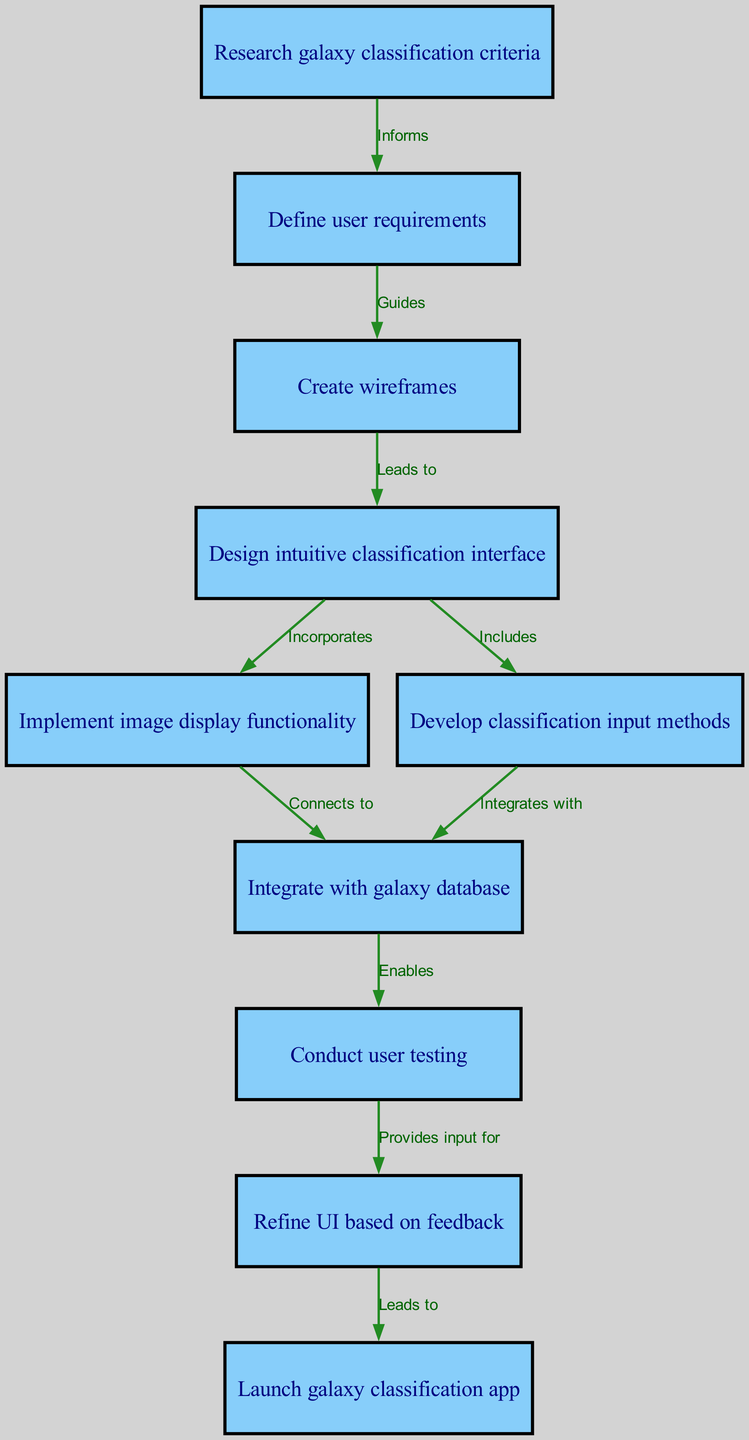What is the first step in the user interface design process? The flow chart shows that the initial step is "Research galaxy classification criteria," which is indicated as the first node numbered 1.
Answer: Research galaxy classification criteria How many nodes are in the diagram? Counting all the nodes listed, there are a total of 10 nodes displayed in the diagram.
Answer: 10 What follows after defining user requirements? According to the diagram, after "Define user requirements," the next step is "Create wireframes," which is the node numbered 3.
Answer: Create wireframes Which process leads to integrating with the galaxy database? The diagram indicates that both image display functionality (node 5) and classification input methods (node 6) connect to "Integrate with galaxy database" (node 7). This shows the relationships leading into that integration step.
Answer: Image display functionality, classification input methods What does user testing enable in the design process? The diagram states that "Conduct user testing" (node 8) enables "Refine UI based on feedback" (node 9), demonstrating a direct connection between these two phases in the process.
Answer: Refine UI based on feedback What is the connection between wireframes and the classification interface design? The flow chart specifies that "Create wireframes" (node 3) leads to "Design intuitive classification interface" (node 4), which shows that wireframes are a critical preliminary step in creating the interface.
Answer: Design intuitive classification interface What is the final step of the user interface design process? The last step in the flow chart is clearly labeled as "Launch galaxy classification app," which is denoted as node number 10, making it the concluding phase.
Answer: Launch galaxy classification app Which node is connected to the implement image display functionality? "Implement image display functionality" (node 5) is directly connected to "Integrate with galaxy database" (node 7), showing that it connects as part of the development process.
Answer: Integrate with galaxy database 